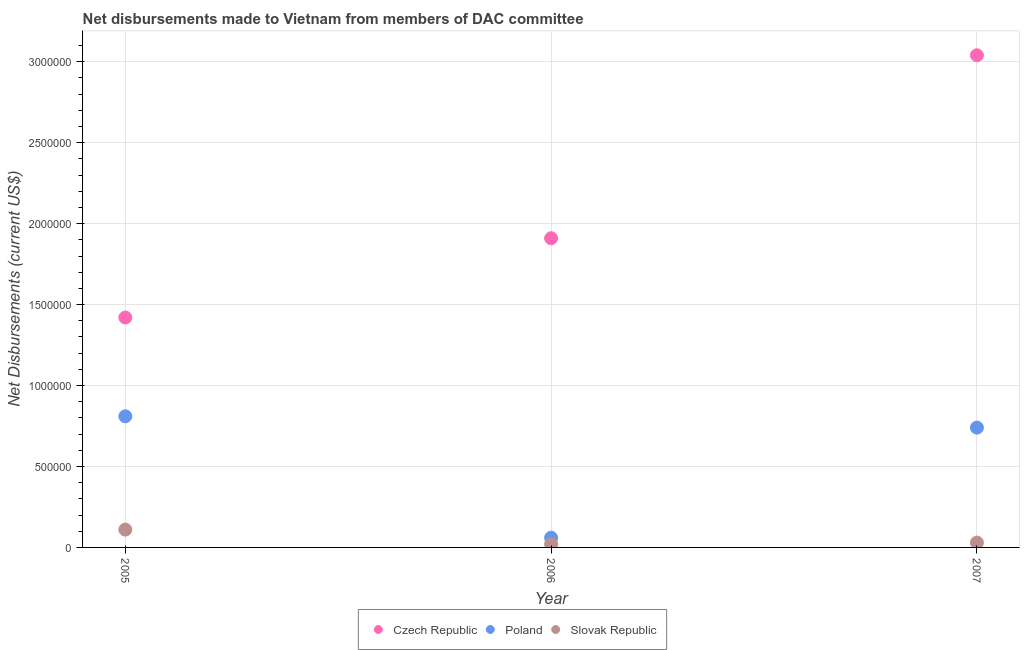How many different coloured dotlines are there?
Your answer should be very brief. 3. What is the net disbursements made by poland in 2006?
Ensure brevity in your answer.  6.00e+04. Across all years, what is the maximum net disbursements made by poland?
Give a very brief answer. 8.10e+05. Across all years, what is the minimum net disbursements made by czech republic?
Your answer should be very brief. 1.42e+06. In which year was the net disbursements made by czech republic maximum?
Keep it short and to the point. 2007. What is the total net disbursements made by poland in the graph?
Make the answer very short. 1.61e+06. What is the difference between the net disbursements made by poland in 2006 and that in 2007?
Offer a terse response. -6.80e+05. What is the difference between the net disbursements made by czech republic in 2007 and the net disbursements made by poland in 2005?
Ensure brevity in your answer.  2.23e+06. What is the average net disbursements made by slovak republic per year?
Your response must be concise. 5.33e+04. In the year 2006, what is the difference between the net disbursements made by czech republic and net disbursements made by slovak republic?
Keep it short and to the point. 1.89e+06. In how many years, is the net disbursements made by slovak republic greater than 1000000 US$?
Keep it short and to the point. 0. What is the ratio of the net disbursements made by czech republic in 2005 to that in 2007?
Keep it short and to the point. 0.47. Is the net disbursements made by poland in 2005 less than that in 2006?
Your response must be concise. No. Is the difference between the net disbursements made by poland in 2005 and 2007 greater than the difference between the net disbursements made by czech republic in 2005 and 2007?
Your answer should be very brief. Yes. What is the difference between the highest and the lowest net disbursements made by poland?
Your response must be concise. 7.50e+05. Is it the case that in every year, the sum of the net disbursements made by czech republic and net disbursements made by poland is greater than the net disbursements made by slovak republic?
Ensure brevity in your answer.  Yes. Is the net disbursements made by poland strictly greater than the net disbursements made by czech republic over the years?
Offer a very short reply. No. How many years are there in the graph?
Make the answer very short. 3. What is the difference between two consecutive major ticks on the Y-axis?
Provide a short and direct response. 5.00e+05. Does the graph contain any zero values?
Your answer should be very brief. No. What is the title of the graph?
Offer a terse response. Net disbursements made to Vietnam from members of DAC committee. Does "Social insurance" appear as one of the legend labels in the graph?
Ensure brevity in your answer.  No. What is the label or title of the X-axis?
Your answer should be very brief. Year. What is the label or title of the Y-axis?
Your answer should be very brief. Net Disbursements (current US$). What is the Net Disbursements (current US$) in Czech Republic in 2005?
Keep it short and to the point. 1.42e+06. What is the Net Disbursements (current US$) in Poland in 2005?
Keep it short and to the point. 8.10e+05. What is the Net Disbursements (current US$) in Czech Republic in 2006?
Make the answer very short. 1.91e+06. What is the Net Disbursements (current US$) of Poland in 2006?
Offer a very short reply. 6.00e+04. What is the Net Disbursements (current US$) in Slovak Republic in 2006?
Give a very brief answer. 2.00e+04. What is the Net Disbursements (current US$) of Czech Republic in 2007?
Make the answer very short. 3.04e+06. What is the Net Disbursements (current US$) in Poland in 2007?
Give a very brief answer. 7.40e+05. What is the Net Disbursements (current US$) of Slovak Republic in 2007?
Keep it short and to the point. 3.00e+04. Across all years, what is the maximum Net Disbursements (current US$) in Czech Republic?
Give a very brief answer. 3.04e+06. Across all years, what is the maximum Net Disbursements (current US$) of Poland?
Provide a succinct answer. 8.10e+05. Across all years, what is the maximum Net Disbursements (current US$) in Slovak Republic?
Offer a very short reply. 1.10e+05. Across all years, what is the minimum Net Disbursements (current US$) of Czech Republic?
Your response must be concise. 1.42e+06. Across all years, what is the minimum Net Disbursements (current US$) of Poland?
Offer a terse response. 6.00e+04. What is the total Net Disbursements (current US$) of Czech Republic in the graph?
Provide a succinct answer. 6.37e+06. What is the total Net Disbursements (current US$) in Poland in the graph?
Keep it short and to the point. 1.61e+06. What is the total Net Disbursements (current US$) of Slovak Republic in the graph?
Offer a very short reply. 1.60e+05. What is the difference between the Net Disbursements (current US$) of Czech Republic in 2005 and that in 2006?
Your answer should be compact. -4.90e+05. What is the difference between the Net Disbursements (current US$) in Poland in 2005 and that in 2006?
Give a very brief answer. 7.50e+05. What is the difference between the Net Disbursements (current US$) in Slovak Republic in 2005 and that in 2006?
Offer a terse response. 9.00e+04. What is the difference between the Net Disbursements (current US$) in Czech Republic in 2005 and that in 2007?
Offer a terse response. -1.62e+06. What is the difference between the Net Disbursements (current US$) of Czech Republic in 2006 and that in 2007?
Your response must be concise. -1.13e+06. What is the difference between the Net Disbursements (current US$) in Poland in 2006 and that in 2007?
Provide a short and direct response. -6.80e+05. What is the difference between the Net Disbursements (current US$) in Czech Republic in 2005 and the Net Disbursements (current US$) in Poland in 2006?
Your response must be concise. 1.36e+06. What is the difference between the Net Disbursements (current US$) of Czech Republic in 2005 and the Net Disbursements (current US$) of Slovak Republic in 2006?
Give a very brief answer. 1.40e+06. What is the difference between the Net Disbursements (current US$) of Poland in 2005 and the Net Disbursements (current US$) of Slovak Republic in 2006?
Your response must be concise. 7.90e+05. What is the difference between the Net Disbursements (current US$) in Czech Republic in 2005 and the Net Disbursements (current US$) in Poland in 2007?
Offer a terse response. 6.80e+05. What is the difference between the Net Disbursements (current US$) in Czech Republic in 2005 and the Net Disbursements (current US$) in Slovak Republic in 2007?
Your response must be concise. 1.39e+06. What is the difference between the Net Disbursements (current US$) of Poland in 2005 and the Net Disbursements (current US$) of Slovak Republic in 2007?
Offer a terse response. 7.80e+05. What is the difference between the Net Disbursements (current US$) in Czech Republic in 2006 and the Net Disbursements (current US$) in Poland in 2007?
Your answer should be compact. 1.17e+06. What is the difference between the Net Disbursements (current US$) of Czech Republic in 2006 and the Net Disbursements (current US$) of Slovak Republic in 2007?
Offer a terse response. 1.88e+06. What is the average Net Disbursements (current US$) in Czech Republic per year?
Offer a terse response. 2.12e+06. What is the average Net Disbursements (current US$) in Poland per year?
Offer a very short reply. 5.37e+05. What is the average Net Disbursements (current US$) of Slovak Republic per year?
Offer a terse response. 5.33e+04. In the year 2005, what is the difference between the Net Disbursements (current US$) of Czech Republic and Net Disbursements (current US$) of Slovak Republic?
Make the answer very short. 1.31e+06. In the year 2006, what is the difference between the Net Disbursements (current US$) in Czech Republic and Net Disbursements (current US$) in Poland?
Your answer should be very brief. 1.85e+06. In the year 2006, what is the difference between the Net Disbursements (current US$) in Czech Republic and Net Disbursements (current US$) in Slovak Republic?
Make the answer very short. 1.89e+06. In the year 2007, what is the difference between the Net Disbursements (current US$) in Czech Republic and Net Disbursements (current US$) in Poland?
Provide a short and direct response. 2.30e+06. In the year 2007, what is the difference between the Net Disbursements (current US$) of Czech Republic and Net Disbursements (current US$) of Slovak Republic?
Offer a very short reply. 3.01e+06. In the year 2007, what is the difference between the Net Disbursements (current US$) of Poland and Net Disbursements (current US$) of Slovak Republic?
Offer a very short reply. 7.10e+05. What is the ratio of the Net Disbursements (current US$) of Czech Republic in 2005 to that in 2006?
Keep it short and to the point. 0.74. What is the ratio of the Net Disbursements (current US$) of Czech Republic in 2005 to that in 2007?
Offer a terse response. 0.47. What is the ratio of the Net Disbursements (current US$) of Poland in 2005 to that in 2007?
Keep it short and to the point. 1.09. What is the ratio of the Net Disbursements (current US$) in Slovak Republic in 2005 to that in 2007?
Provide a succinct answer. 3.67. What is the ratio of the Net Disbursements (current US$) in Czech Republic in 2006 to that in 2007?
Your response must be concise. 0.63. What is the ratio of the Net Disbursements (current US$) in Poland in 2006 to that in 2007?
Keep it short and to the point. 0.08. What is the ratio of the Net Disbursements (current US$) in Slovak Republic in 2006 to that in 2007?
Ensure brevity in your answer.  0.67. What is the difference between the highest and the second highest Net Disbursements (current US$) in Czech Republic?
Offer a very short reply. 1.13e+06. What is the difference between the highest and the second highest Net Disbursements (current US$) in Poland?
Make the answer very short. 7.00e+04. What is the difference between the highest and the second highest Net Disbursements (current US$) of Slovak Republic?
Offer a very short reply. 8.00e+04. What is the difference between the highest and the lowest Net Disbursements (current US$) in Czech Republic?
Your response must be concise. 1.62e+06. What is the difference between the highest and the lowest Net Disbursements (current US$) in Poland?
Keep it short and to the point. 7.50e+05. 